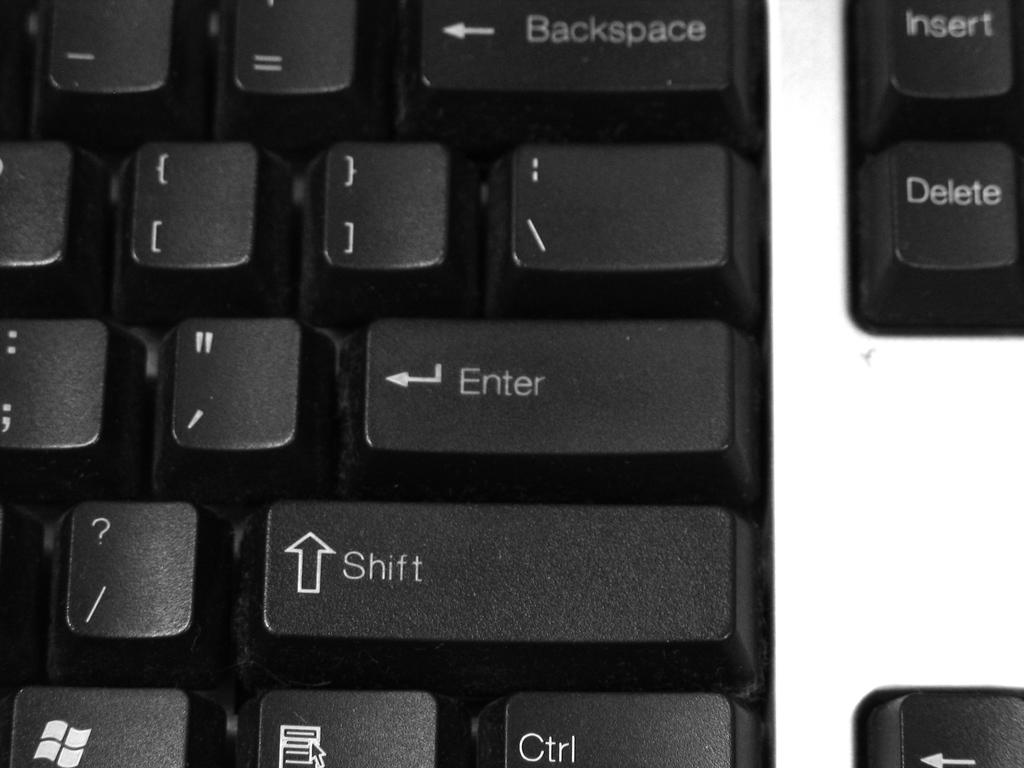Provide a one-sentence caption for the provided image. A close up of a keyboard showing several keys including the enter and shift key. 